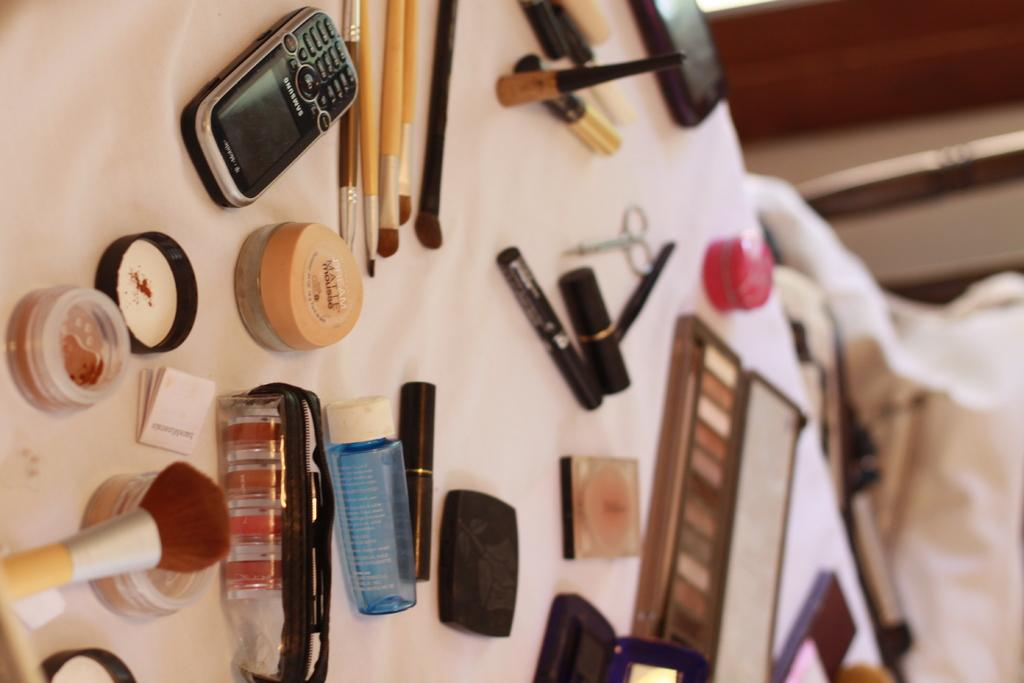<image>
Offer a succinct explanation of the picture presented. A samsung phone is on a table next to some make up 